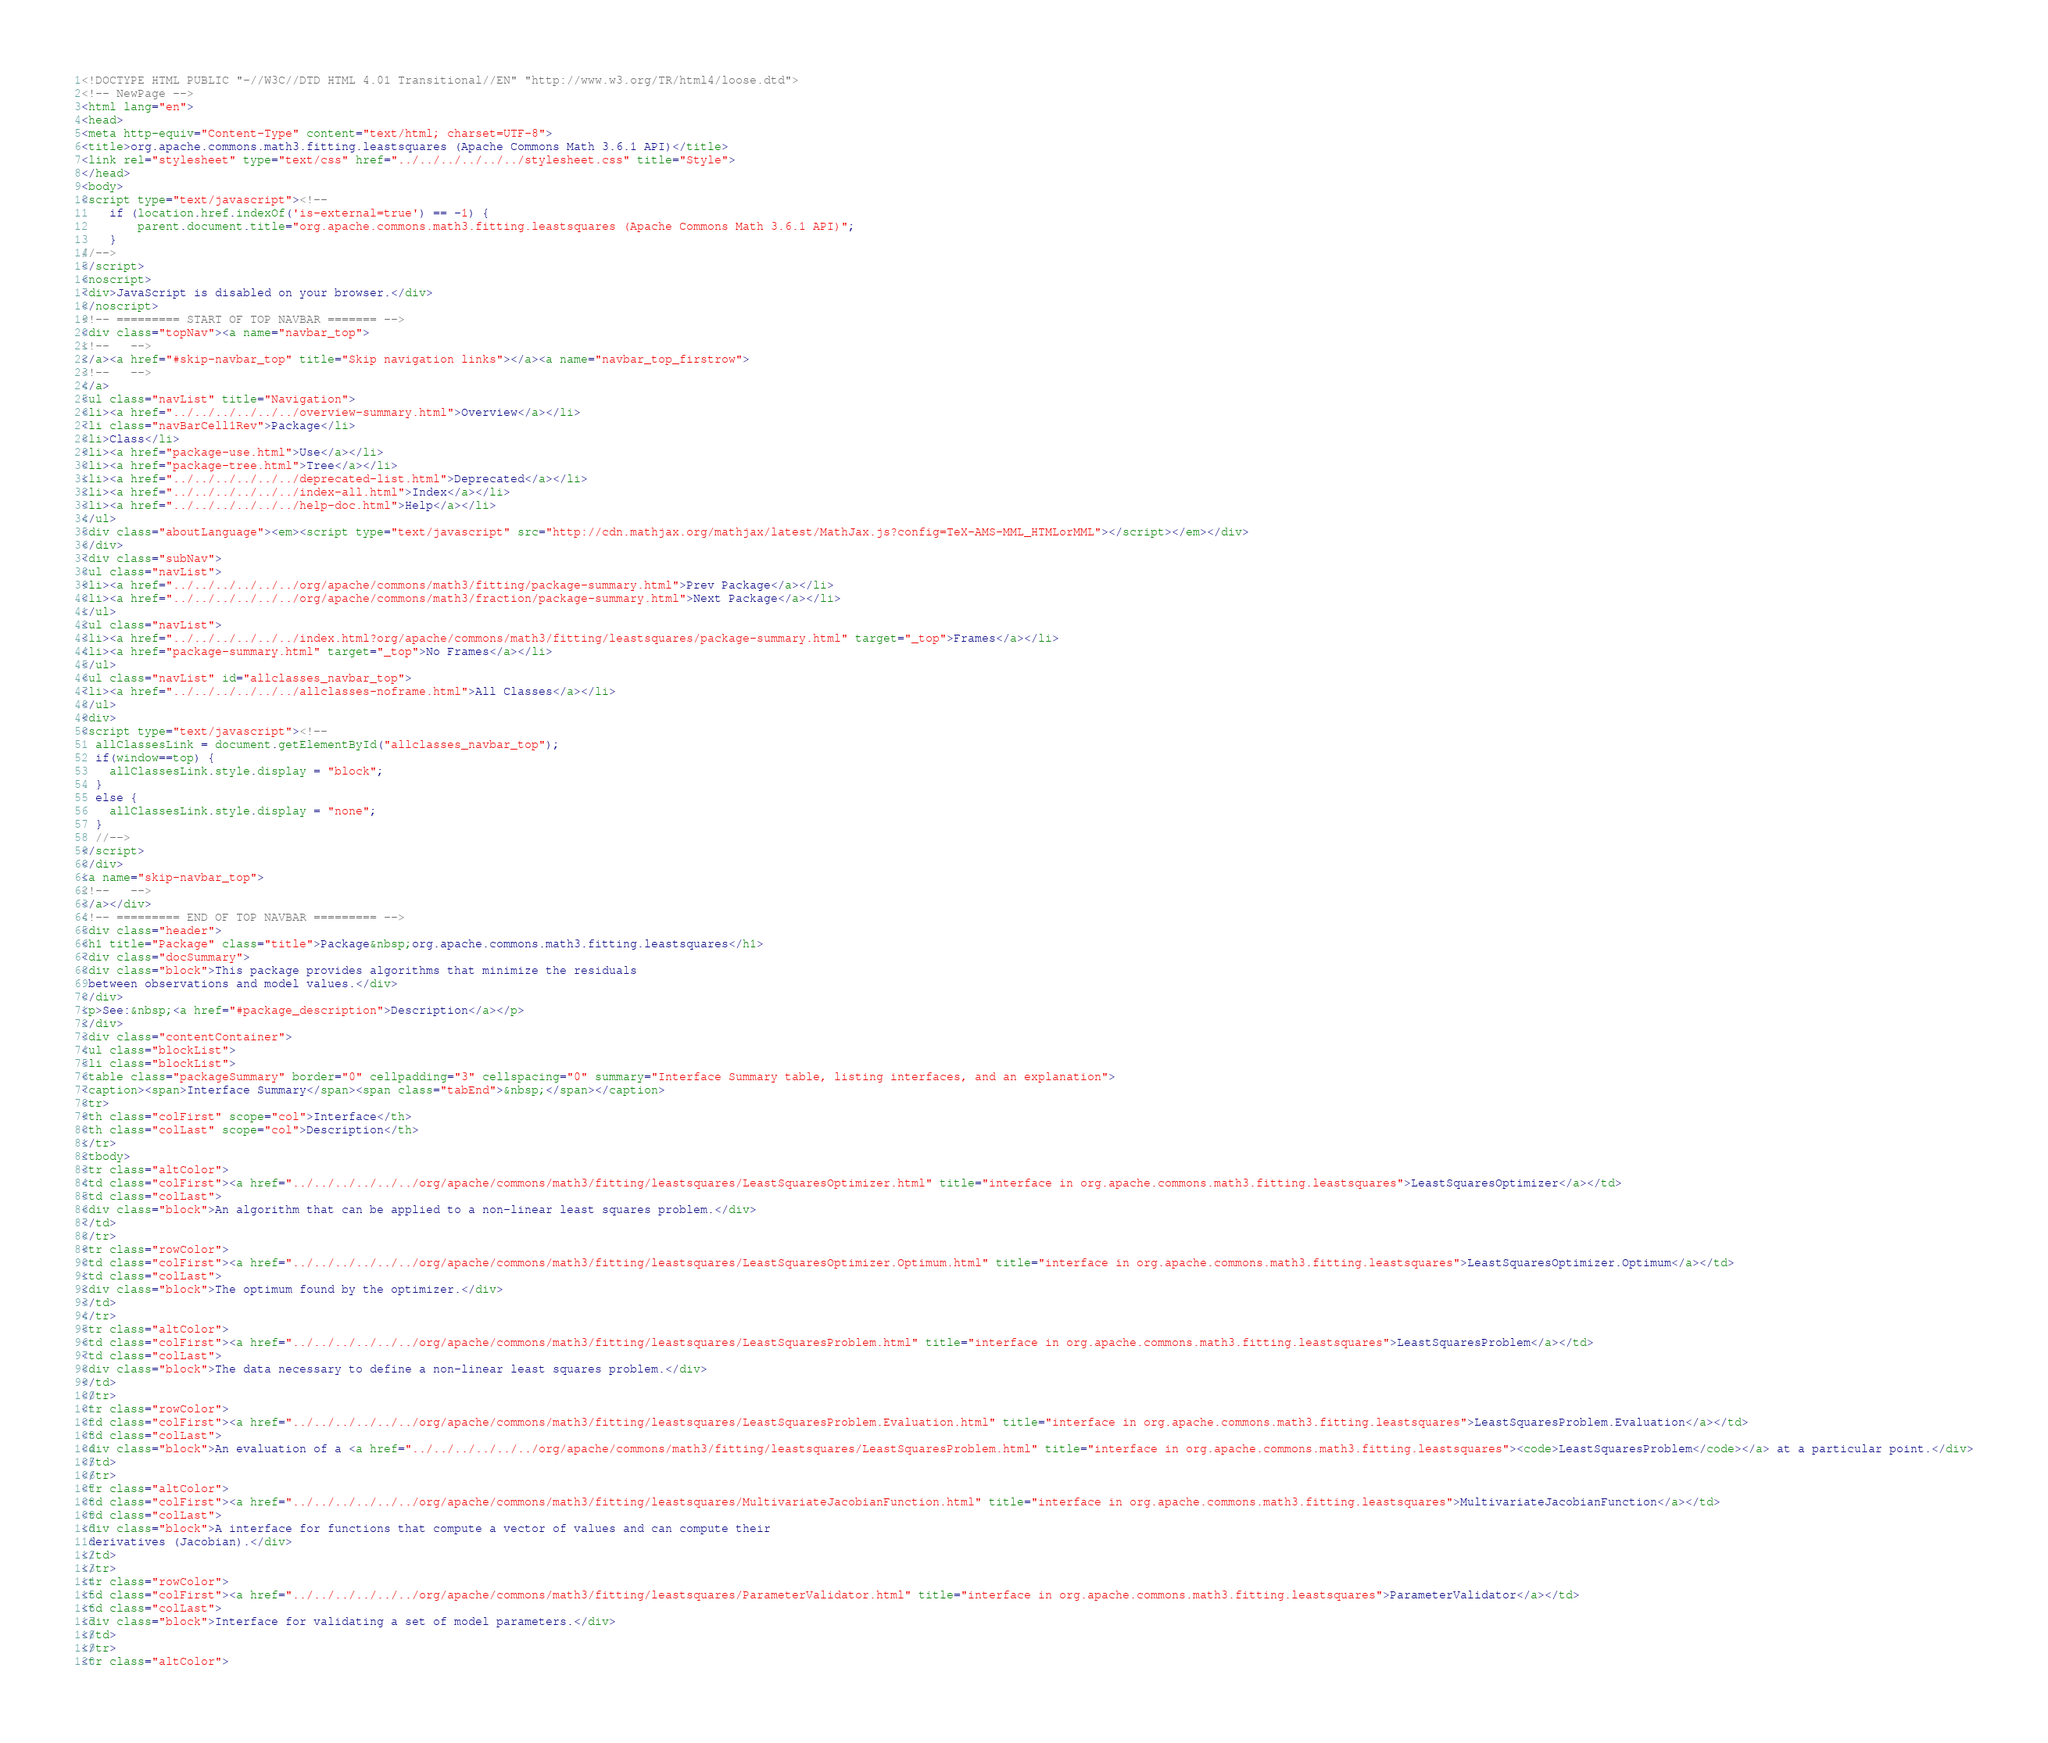<code> <loc_0><loc_0><loc_500><loc_500><_HTML_><!DOCTYPE HTML PUBLIC "-//W3C//DTD HTML 4.01 Transitional//EN" "http://www.w3.org/TR/html4/loose.dtd">
<!-- NewPage -->
<html lang="en">
<head>
<meta http-equiv="Content-Type" content="text/html; charset=UTF-8">
<title>org.apache.commons.math3.fitting.leastsquares (Apache Commons Math 3.6.1 API)</title>
<link rel="stylesheet" type="text/css" href="../../../../../../stylesheet.css" title="Style">
</head>
<body>
<script type="text/javascript"><!--
    if (location.href.indexOf('is-external=true') == -1) {
        parent.document.title="org.apache.commons.math3.fitting.leastsquares (Apache Commons Math 3.6.1 API)";
    }
//-->
</script>
<noscript>
<div>JavaScript is disabled on your browser.</div>
</noscript>
<!-- ========= START OF TOP NAVBAR ======= -->
<div class="topNav"><a name="navbar_top">
<!--   -->
</a><a href="#skip-navbar_top" title="Skip navigation links"></a><a name="navbar_top_firstrow">
<!--   -->
</a>
<ul class="navList" title="Navigation">
<li><a href="../../../../../../overview-summary.html">Overview</a></li>
<li class="navBarCell1Rev">Package</li>
<li>Class</li>
<li><a href="package-use.html">Use</a></li>
<li><a href="package-tree.html">Tree</a></li>
<li><a href="../../../../../../deprecated-list.html">Deprecated</a></li>
<li><a href="../../../../../../index-all.html">Index</a></li>
<li><a href="../../../../../../help-doc.html">Help</a></li>
</ul>
<div class="aboutLanguage"><em><script type="text/javascript" src="http://cdn.mathjax.org/mathjax/latest/MathJax.js?config=TeX-AMS-MML_HTMLorMML"></script></em></div>
</div>
<div class="subNav">
<ul class="navList">
<li><a href="../../../../../../org/apache/commons/math3/fitting/package-summary.html">Prev Package</a></li>
<li><a href="../../../../../../org/apache/commons/math3/fraction/package-summary.html">Next Package</a></li>
</ul>
<ul class="navList">
<li><a href="../../../../../../index.html?org/apache/commons/math3/fitting/leastsquares/package-summary.html" target="_top">Frames</a></li>
<li><a href="package-summary.html" target="_top">No Frames</a></li>
</ul>
<ul class="navList" id="allclasses_navbar_top">
<li><a href="../../../../../../allclasses-noframe.html">All Classes</a></li>
</ul>
<div>
<script type="text/javascript"><!--
  allClassesLink = document.getElementById("allclasses_navbar_top");
  if(window==top) {
    allClassesLink.style.display = "block";
  }
  else {
    allClassesLink.style.display = "none";
  }
  //-->
</script>
</div>
<a name="skip-navbar_top">
<!--   -->
</a></div>
<!-- ========= END OF TOP NAVBAR ========= -->
<div class="header">
<h1 title="Package" class="title">Package&nbsp;org.apache.commons.math3.fitting.leastsquares</h1>
<div class="docSummary">
<div class="block">This package provides algorithms that minimize the residuals
 between observations and model values.</div>
</div>
<p>See:&nbsp;<a href="#package_description">Description</a></p>
</div>
<div class="contentContainer">
<ul class="blockList">
<li class="blockList">
<table class="packageSummary" border="0" cellpadding="3" cellspacing="0" summary="Interface Summary table, listing interfaces, and an explanation">
<caption><span>Interface Summary</span><span class="tabEnd">&nbsp;</span></caption>
<tr>
<th class="colFirst" scope="col">Interface</th>
<th class="colLast" scope="col">Description</th>
</tr>
<tbody>
<tr class="altColor">
<td class="colFirst"><a href="../../../../../../org/apache/commons/math3/fitting/leastsquares/LeastSquaresOptimizer.html" title="interface in org.apache.commons.math3.fitting.leastsquares">LeastSquaresOptimizer</a></td>
<td class="colLast">
<div class="block">An algorithm that can be applied to a non-linear least squares problem.</div>
</td>
</tr>
<tr class="rowColor">
<td class="colFirst"><a href="../../../../../../org/apache/commons/math3/fitting/leastsquares/LeastSquaresOptimizer.Optimum.html" title="interface in org.apache.commons.math3.fitting.leastsquares">LeastSquaresOptimizer.Optimum</a></td>
<td class="colLast">
<div class="block">The optimum found by the optimizer.</div>
</td>
</tr>
<tr class="altColor">
<td class="colFirst"><a href="../../../../../../org/apache/commons/math3/fitting/leastsquares/LeastSquaresProblem.html" title="interface in org.apache.commons.math3.fitting.leastsquares">LeastSquaresProblem</a></td>
<td class="colLast">
<div class="block">The data necessary to define a non-linear least squares problem.</div>
</td>
</tr>
<tr class="rowColor">
<td class="colFirst"><a href="../../../../../../org/apache/commons/math3/fitting/leastsquares/LeastSquaresProblem.Evaluation.html" title="interface in org.apache.commons.math3.fitting.leastsquares">LeastSquaresProblem.Evaluation</a></td>
<td class="colLast">
<div class="block">An evaluation of a <a href="../../../../../../org/apache/commons/math3/fitting/leastsquares/LeastSquaresProblem.html" title="interface in org.apache.commons.math3.fitting.leastsquares"><code>LeastSquaresProblem</code></a> at a particular point.</div>
</td>
</tr>
<tr class="altColor">
<td class="colFirst"><a href="../../../../../../org/apache/commons/math3/fitting/leastsquares/MultivariateJacobianFunction.html" title="interface in org.apache.commons.math3.fitting.leastsquares">MultivariateJacobianFunction</a></td>
<td class="colLast">
<div class="block">A interface for functions that compute a vector of values and can compute their
 derivatives (Jacobian).</div>
</td>
</tr>
<tr class="rowColor">
<td class="colFirst"><a href="../../../../../../org/apache/commons/math3/fitting/leastsquares/ParameterValidator.html" title="interface in org.apache.commons.math3.fitting.leastsquares">ParameterValidator</a></td>
<td class="colLast">
<div class="block">Interface for validating a set of model parameters.</div>
</td>
</tr>
<tr class="altColor"></code> 